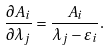<formula> <loc_0><loc_0><loc_500><loc_500>\frac { \partial A _ { i } } { \partial \lambda _ { j } } = \frac { A _ { i } } { \lambda _ { j } - \varepsilon _ { i } } .</formula> 